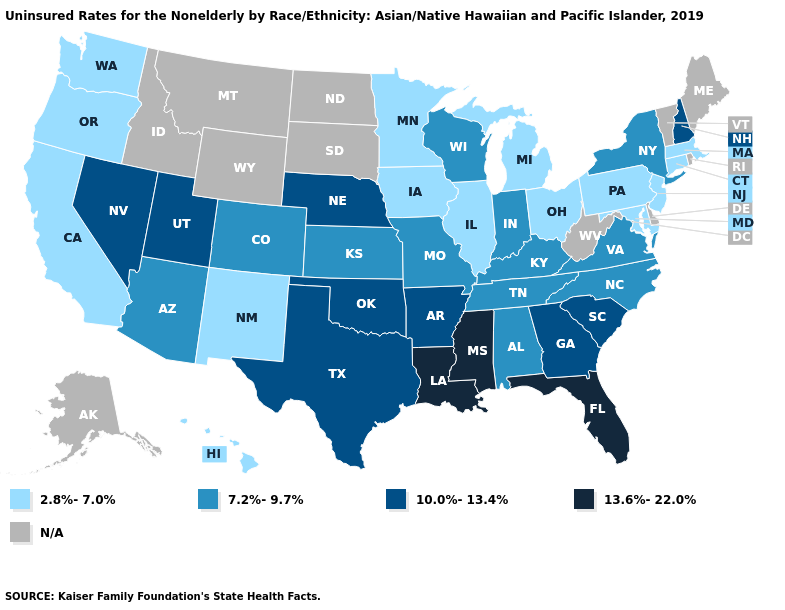Does New Hampshire have the lowest value in the Northeast?
Write a very short answer. No. Among the states that border New Mexico , which have the highest value?
Keep it brief. Oklahoma, Texas, Utah. Name the states that have a value in the range 7.2%-9.7%?
Concise answer only. Alabama, Arizona, Colorado, Indiana, Kansas, Kentucky, Missouri, New York, North Carolina, Tennessee, Virginia, Wisconsin. Name the states that have a value in the range 7.2%-9.7%?
Be succinct. Alabama, Arizona, Colorado, Indiana, Kansas, Kentucky, Missouri, New York, North Carolina, Tennessee, Virginia, Wisconsin. Among the states that border Iowa , which have the lowest value?
Write a very short answer. Illinois, Minnesota. Which states hav the highest value in the MidWest?
Answer briefly. Nebraska. Which states have the highest value in the USA?
Write a very short answer. Florida, Louisiana, Mississippi. What is the lowest value in the USA?
Write a very short answer. 2.8%-7.0%. What is the value of New Mexico?
Keep it brief. 2.8%-7.0%. What is the value of Massachusetts?
Write a very short answer. 2.8%-7.0%. What is the highest value in the Northeast ?
Answer briefly. 10.0%-13.4%. Name the states that have a value in the range N/A?
Concise answer only. Alaska, Delaware, Idaho, Maine, Montana, North Dakota, Rhode Island, South Dakota, Vermont, West Virginia, Wyoming. What is the highest value in the USA?
Quick response, please. 13.6%-22.0%. 